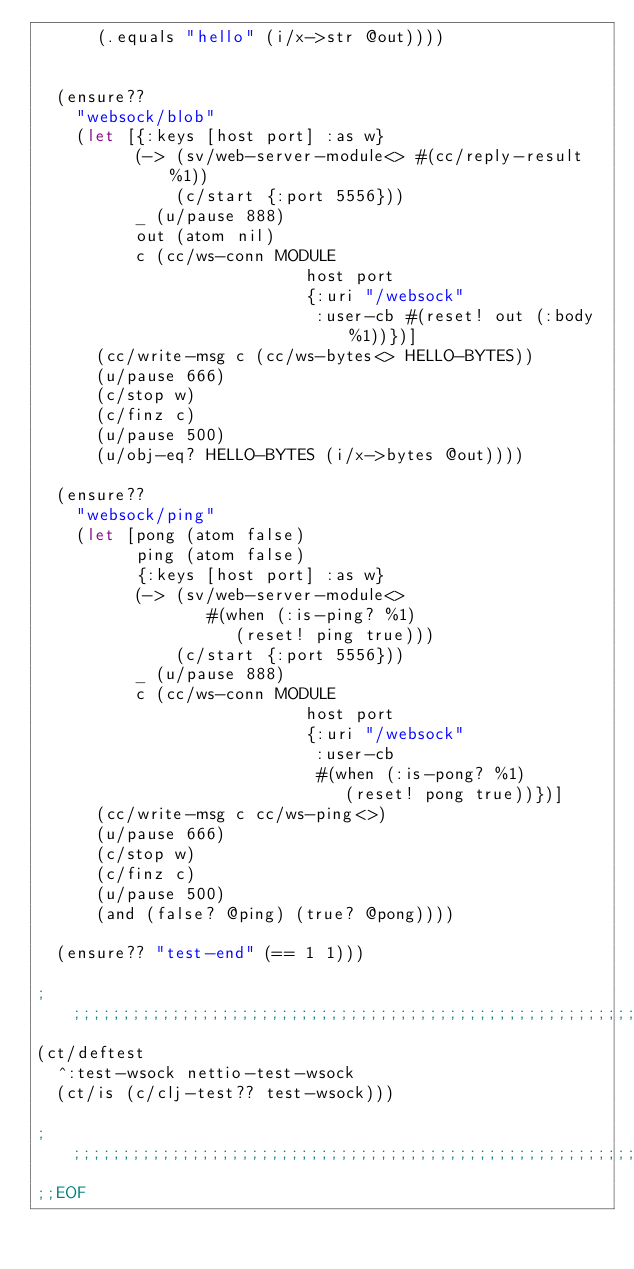Convert code to text. <code><loc_0><loc_0><loc_500><loc_500><_Clojure_>      (.equals "hello" (i/x->str @out))))


  (ensure??
    "websock/blob"
    (let [{:keys [host port] :as w}
          (-> (sv/web-server-module<> #(cc/reply-result %1))
              (c/start {:port 5556}))
          _ (u/pause 888)
          out (atom nil)
          c (cc/ws-conn MODULE
                           host port
                           {:uri "/websock"
                            :user-cb #(reset! out (:body %1))})]
      (cc/write-msg c (cc/ws-bytes<> HELLO-BYTES))
      (u/pause 666)
      (c/stop w)
      (c/finz c)
      (u/pause 500)
      (u/obj-eq? HELLO-BYTES (i/x->bytes @out))))

  (ensure??
    "websock/ping"
    (let [pong (atom false)
          ping (atom false)
          {:keys [host port] :as w}
          (-> (sv/web-server-module<>
                 #(when (:is-ping? %1)
                    (reset! ping true)))
              (c/start {:port 5556}))
          _ (u/pause 888)
          c (cc/ws-conn MODULE
                           host port
                           {:uri "/websock"
                            :user-cb
                            #(when (:is-pong? %1)
                               (reset! pong true))})]
      (cc/write-msg c cc/ws-ping<>)
      (u/pause 666)
      (c/stop w)
      (c/finz c)
      (u/pause 500)
      (and (false? @ping) (true? @pong))))

  (ensure?? "test-end" (== 1 1)))

;;;;;;;;;;;;;;;;;;;;;;;;;;;;;;;;;;;;;;;;;;;;;;;;;;;;;;;;;;;;;;;;;;;;;;;;;;;;;;
(ct/deftest
  ^:test-wsock nettio-test-wsock
  (ct/is (c/clj-test?? test-wsock)))

;;;;;;;;;;;;;;;;;;;;;;;;;;;;;;;;;;;;;;;;;;;;;;;;;;;;;;;;;;;;;;;;;;;;;;;;;;;;;;
;;EOF


</code> 